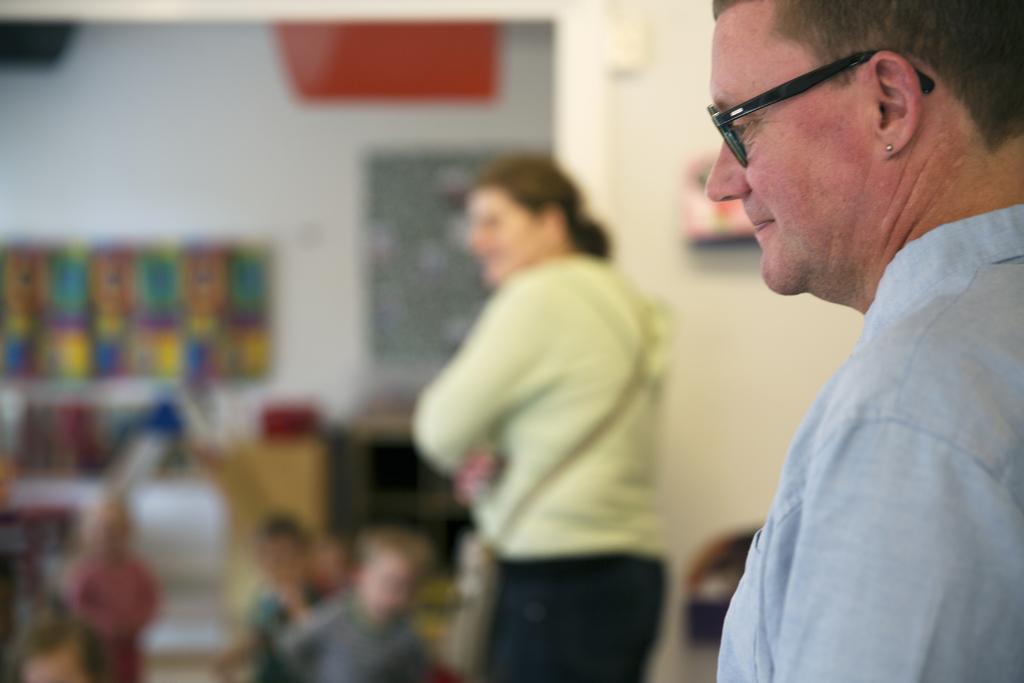Please provide a concise description of this image. On the right side of the image there are two people. In front of them there are kids. There are posters attached to the wall and the background of the image is blur. 